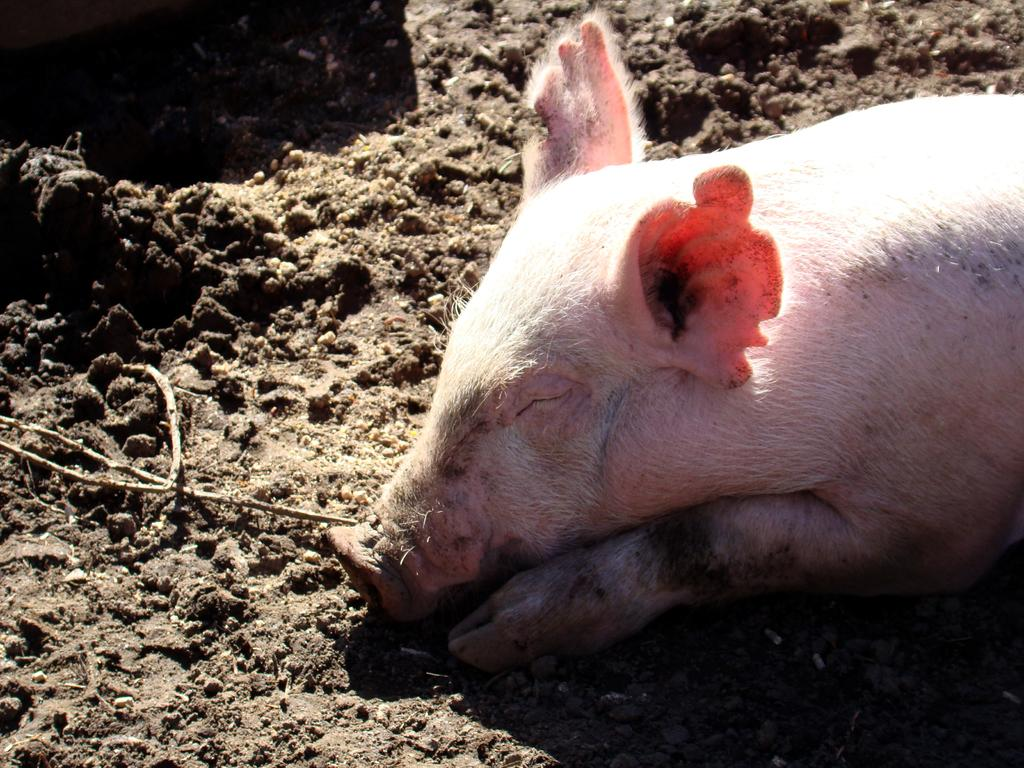What animal is present in the image? There is a pig in the image. What is the position of the pig in the image? The pig is lying on the ground. Are there any cobwebs visible in the image? There is no mention of cobwebs in the provided facts, and therefore we cannot determine if any are present in the image. 